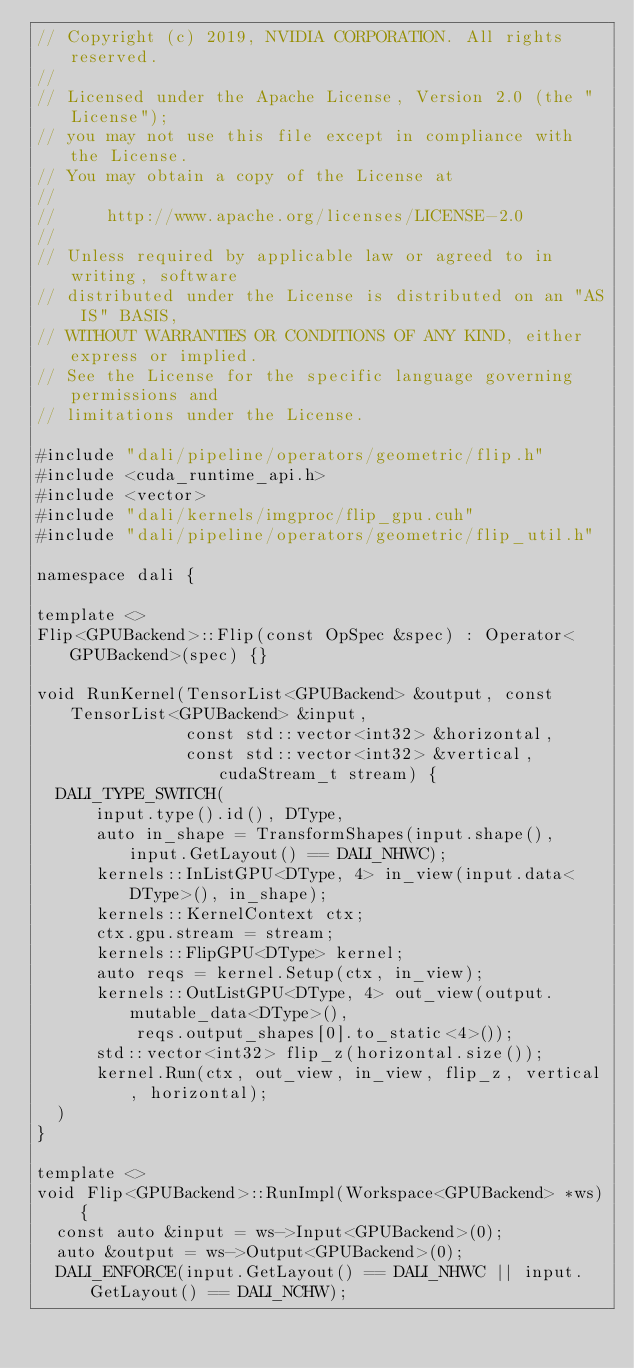<code> <loc_0><loc_0><loc_500><loc_500><_Cuda_>// Copyright (c) 2019, NVIDIA CORPORATION. All rights reserved.
//
// Licensed under the Apache License, Version 2.0 (the "License");
// you may not use this file except in compliance with the License.
// You may obtain a copy of the License at
//
//     http://www.apache.org/licenses/LICENSE-2.0
//
// Unless required by applicable law or agreed to in writing, software
// distributed under the License is distributed on an "AS IS" BASIS,
// WITHOUT WARRANTIES OR CONDITIONS OF ANY KIND, either express or implied.
// See the License for the specific language governing permissions and
// limitations under the License.

#include "dali/pipeline/operators/geometric/flip.h"
#include <cuda_runtime_api.h>
#include <vector>
#include "dali/kernels/imgproc/flip_gpu.cuh"
#include "dali/pipeline/operators/geometric/flip_util.h"

namespace dali {

template <>
Flip<GPUBackend>::Flip(const OpSpec &spec) : Operator<GPUBackend>(spec) {}

void RunKernel(TensorList<GPUBackend> &output, const TensorList<GPUBackend> &input,
               const std::vector<int32> &horizontal,
               const std::vector<int32> &vertical, cudaStream_t stream) {
  DALI_TYPE_SWITCH(
      input.type().id(), DType,
      auto in_shape = TransformShapes(input.shape(), input.GetLayout() == DALI_NHWC);
      kernels::InListGPU<DType, 4> in_view(input.data<DType>(), in_shape);
      kernels::KernelContext ctx;
      ctx.gpu.stream = stream;
      kernels::FlipGPU<DType> kernel;
      auto reqs = kernel.Setup(ctx, in_view);
      kernels::OutListGPU<DType, 4> out_view(output.mutable_data<DType>(),
          reqs.output_shapes[0].to_static<4>());
      std::vector<int32> flip_z(horizontal.size());
      kernel.Run(ctx, out_view, in_view, flip_z, vertical, horizontal);
  )
}

template <>
void Flip<GPUBackend>::RunImpl(Workspace<GPUBackend> *ws) {
  const auto &input = ws->Input<GPUBackend>(0);
  auto &output = ws->Output<GPUBackend>(0);
  DALI_ENFORCE(input.GetLayout() == DALI_NHWC || input.GetLayout() == DALI_NCHW);</code> 